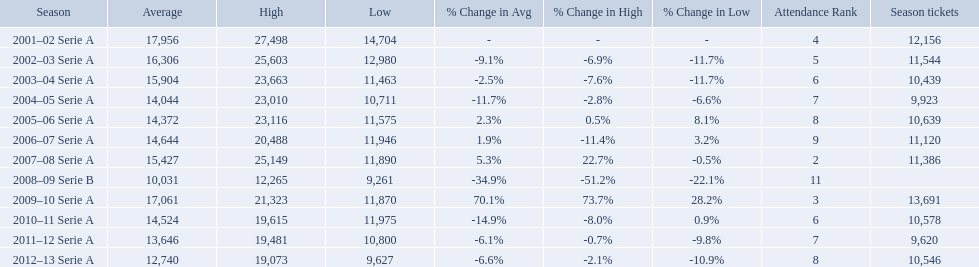When were all of the seasons? 2001–02 Serie A, 2002–03 Serie A, 2003–04 Serie A, 2004–05 Serie A, 2005–06 Serie A, 2006–07 Serie A, 2007–08 Serie A, 2008–09 Serie B, 2009–10 Serie A, 2010–11 Serie A, 2011–12 Serie A, 2012–13 Serie A. How many tickets were sold? 12,156, 11,544, 10,439, 9,923, 10,639, 11,120, 11,386, , 13,691, 10,578, 9,620, 10,546. What about just during the 2007 season? 11,386. Parse the table in full. {'header': ['Season', 'Average', 'High', 'Low', '% Change in Avg', '% Change in High', '% Change in Low', 'Attendance Rank', 'Season tickets'], 'rows': [['2001–02 Serie A', '17,956', '27,498', '14,704', '-', '-', '-', '4', '12,156'], ['2002–03 Serie A', '16,306', '25,603', '12,980', '-9.1%', '-6.9%', '-11.7%', '5', '11,544'], ['2003–04 Serie A', '15,904', '23,663', '11,463', '-2.5%', '-7.6%', '-11.7%', '6', '10,439'], ['2004–05 Serie A', '14,044', '23,010', '10,711', '-11.7%', '-2.8%', '-6.6%', '7', '9,923'], ['2005–06 Serie A', '14,372', '23,116', '11,575', '2.3%', '0.5%', '8.1%', '8', '10,639'], ['2006–07 Serie A', '14,644', '20,488', '11,946', '1.9%', '-11.4%', '3.2%', '9', '11,120'], ['2007–08 Serie A', '15,427', '25,149', '11,890', '5.3%', '22.7%', '-0.5%', '2', '11,386'], ['2008–09 Serie B', '10,031', '12,265', '9,261', '-34.9%', '-51.2%', '-22.1%', '11', ''], ['2009–10 Serie A', '17,061', '21,323', '11,870', '70.1%', '73.7%', '28.2%', '3', '13,691'], ['2010–11 Serie A', '14,524', '19,615', '11,975', '-14.9%', '-8.0%', '0.9%', '6', '10,578'], ['2011–12 Serie A', '13,646', '19,481', '10,800', '-6.1%', '-0.7%', '-9.8%', '7', '9,620'], ['2012–13 Serie A', '12,740', '19,073', '9,627', '-6.6%', '-2.1%', '-10.9%', '8', '10,546']]} What are the seasons? 2001–02 Serie A, 2002–03 Serie A, 2003–04 Serie A, 2004–05 Serie A, 2005–06 Serie A, 2006–07 Serie A, 2007–08 Serie A, 2008–09 Serie B, 2009–10 Serie A, 2010–11 Serie A, 2011–12 Serie A, 2012–13 Serie A. Which season is in 2007? 2007–08 Serie A. How many season tickets were sold that season? 11,386. 